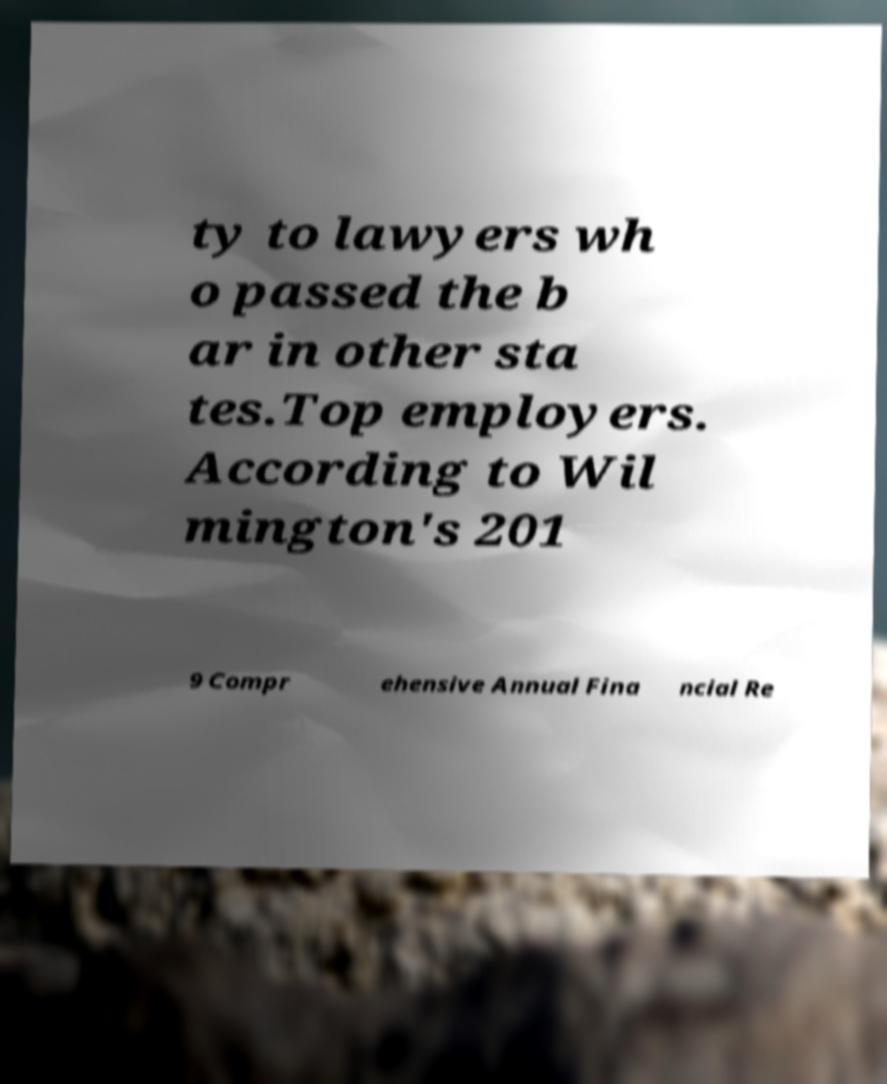What messages or text are displayed in this image? I need them in a readable, typed format. ty to lawyers wh o passed the b ar in other sta tes.Top employers. According to Wil mington's 201 9 Compr ehensive Annual Fina ncial Re 